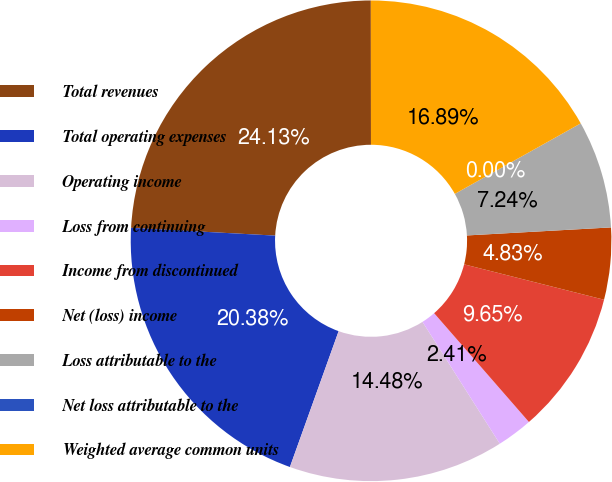Convert chart to OTSL. <chart><loc_0><loc_0><loc_500><loc_500><pie_chart><fcel>Total revenues<fcel>Total operating expenses<fcel>Operating income<fcel>Loss from continuing<fcel>Income from discontinued<fcel>Net (loss) income<fcel>Loss attributable to the<fcel>Net loss attributable to the<fcel>Weighted average common units<nl><fcel>24.13%<fcel>20.38%<fcel>14.48%<fcel>2.41%<fcel>9.65%<fcel>4.83%<fcel>7.24%<fcel>0.0%<fcel>16.89%<nl></chart> 